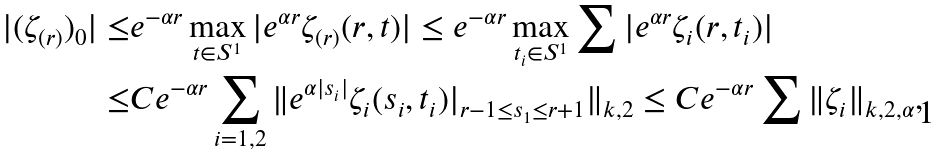<formula> <loc_0><loc_0><loc_500><loc_500>| ( \zeta _ { ( r ) } ) _ { 0 } | \leq & e ^ { - \alpha r } \max _ { t \in S ^ { 1 } } | e ^ { \alpha r } \zeta _ { ( r ) } ( r , t ) | \leq e ^ { - \alpha r } \max _ { t _ { i } \in S ^ { 1 } } \sum | e ^ { \alpha r } \zeta _ { i } ( r , t _ { i } ) | \\ \leq & C e ^ { - \alpha r } \sum _ { i = 1 , 2 } \| e ^ { \alpha | s _ { i } | } \zeta _ { i } ( s _ { i } , t _ { i } ) | _ { r - 1 \leq s _ { 1 } \leq r + 1 } \| _ { k , 2 } \leq C e ^ { - \alpha r } \sum \| \zeta _ { i } \| _ { k , 2 , \alpha } ,</formula> 